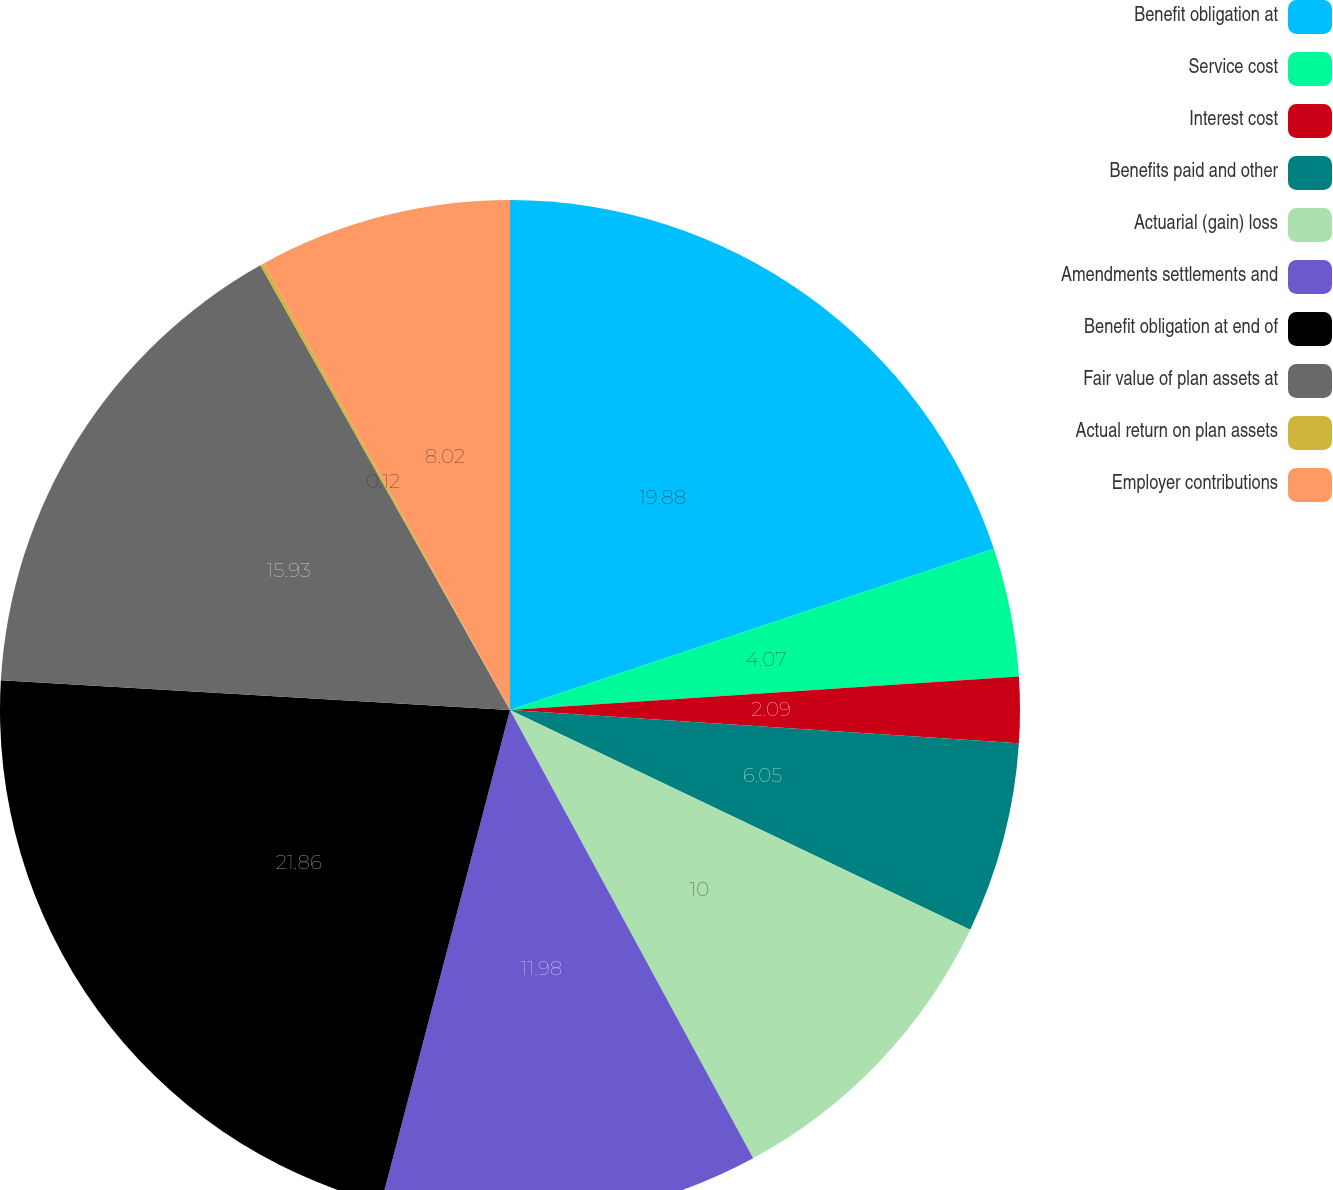Convert chart to OTSL. <chart><loc_0><loc_0><loc_500><loc_500><pie_chart><fcel>Benefit obligation at<fcel>Service cost<fcel>Interest cost<fcel>Benefits paid and other<fcel>Actuarial (gain) loss<fcel>Amendments settlements and<fcel>Benefit obligation at end of<fcel>Fair value of plan assets at<fcel>Actual return on plan assets<fcel>Employer contributions<nl><fcel>19.88%<fcel>4.07%<fcel>2.09%<fcel>6.05%<fcel>10.0%<fcel>11.98%<fcel>21.86%<fcel>15.93%<fcel>0.12%<fcel>8.02%<nl></chart> 